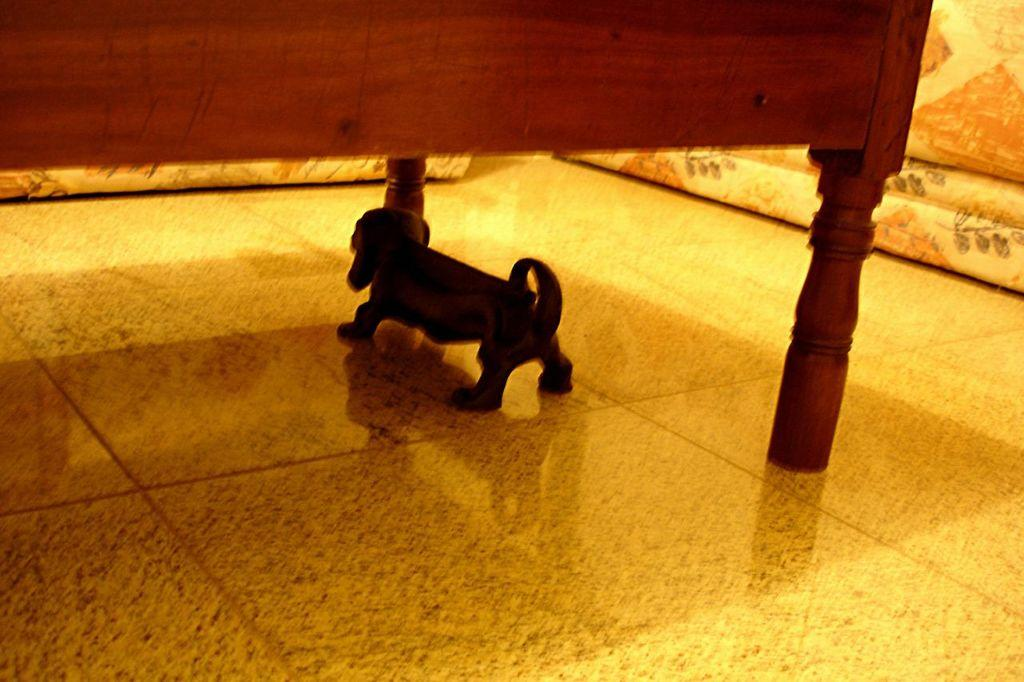What type of animal is in the image? There is a dog in the image. Where is the dog located in the image? The dog is under the bed. What type of fruit is the dog eating in the image? There is no fruit present in the image, and the dog is not shown eating anything. 